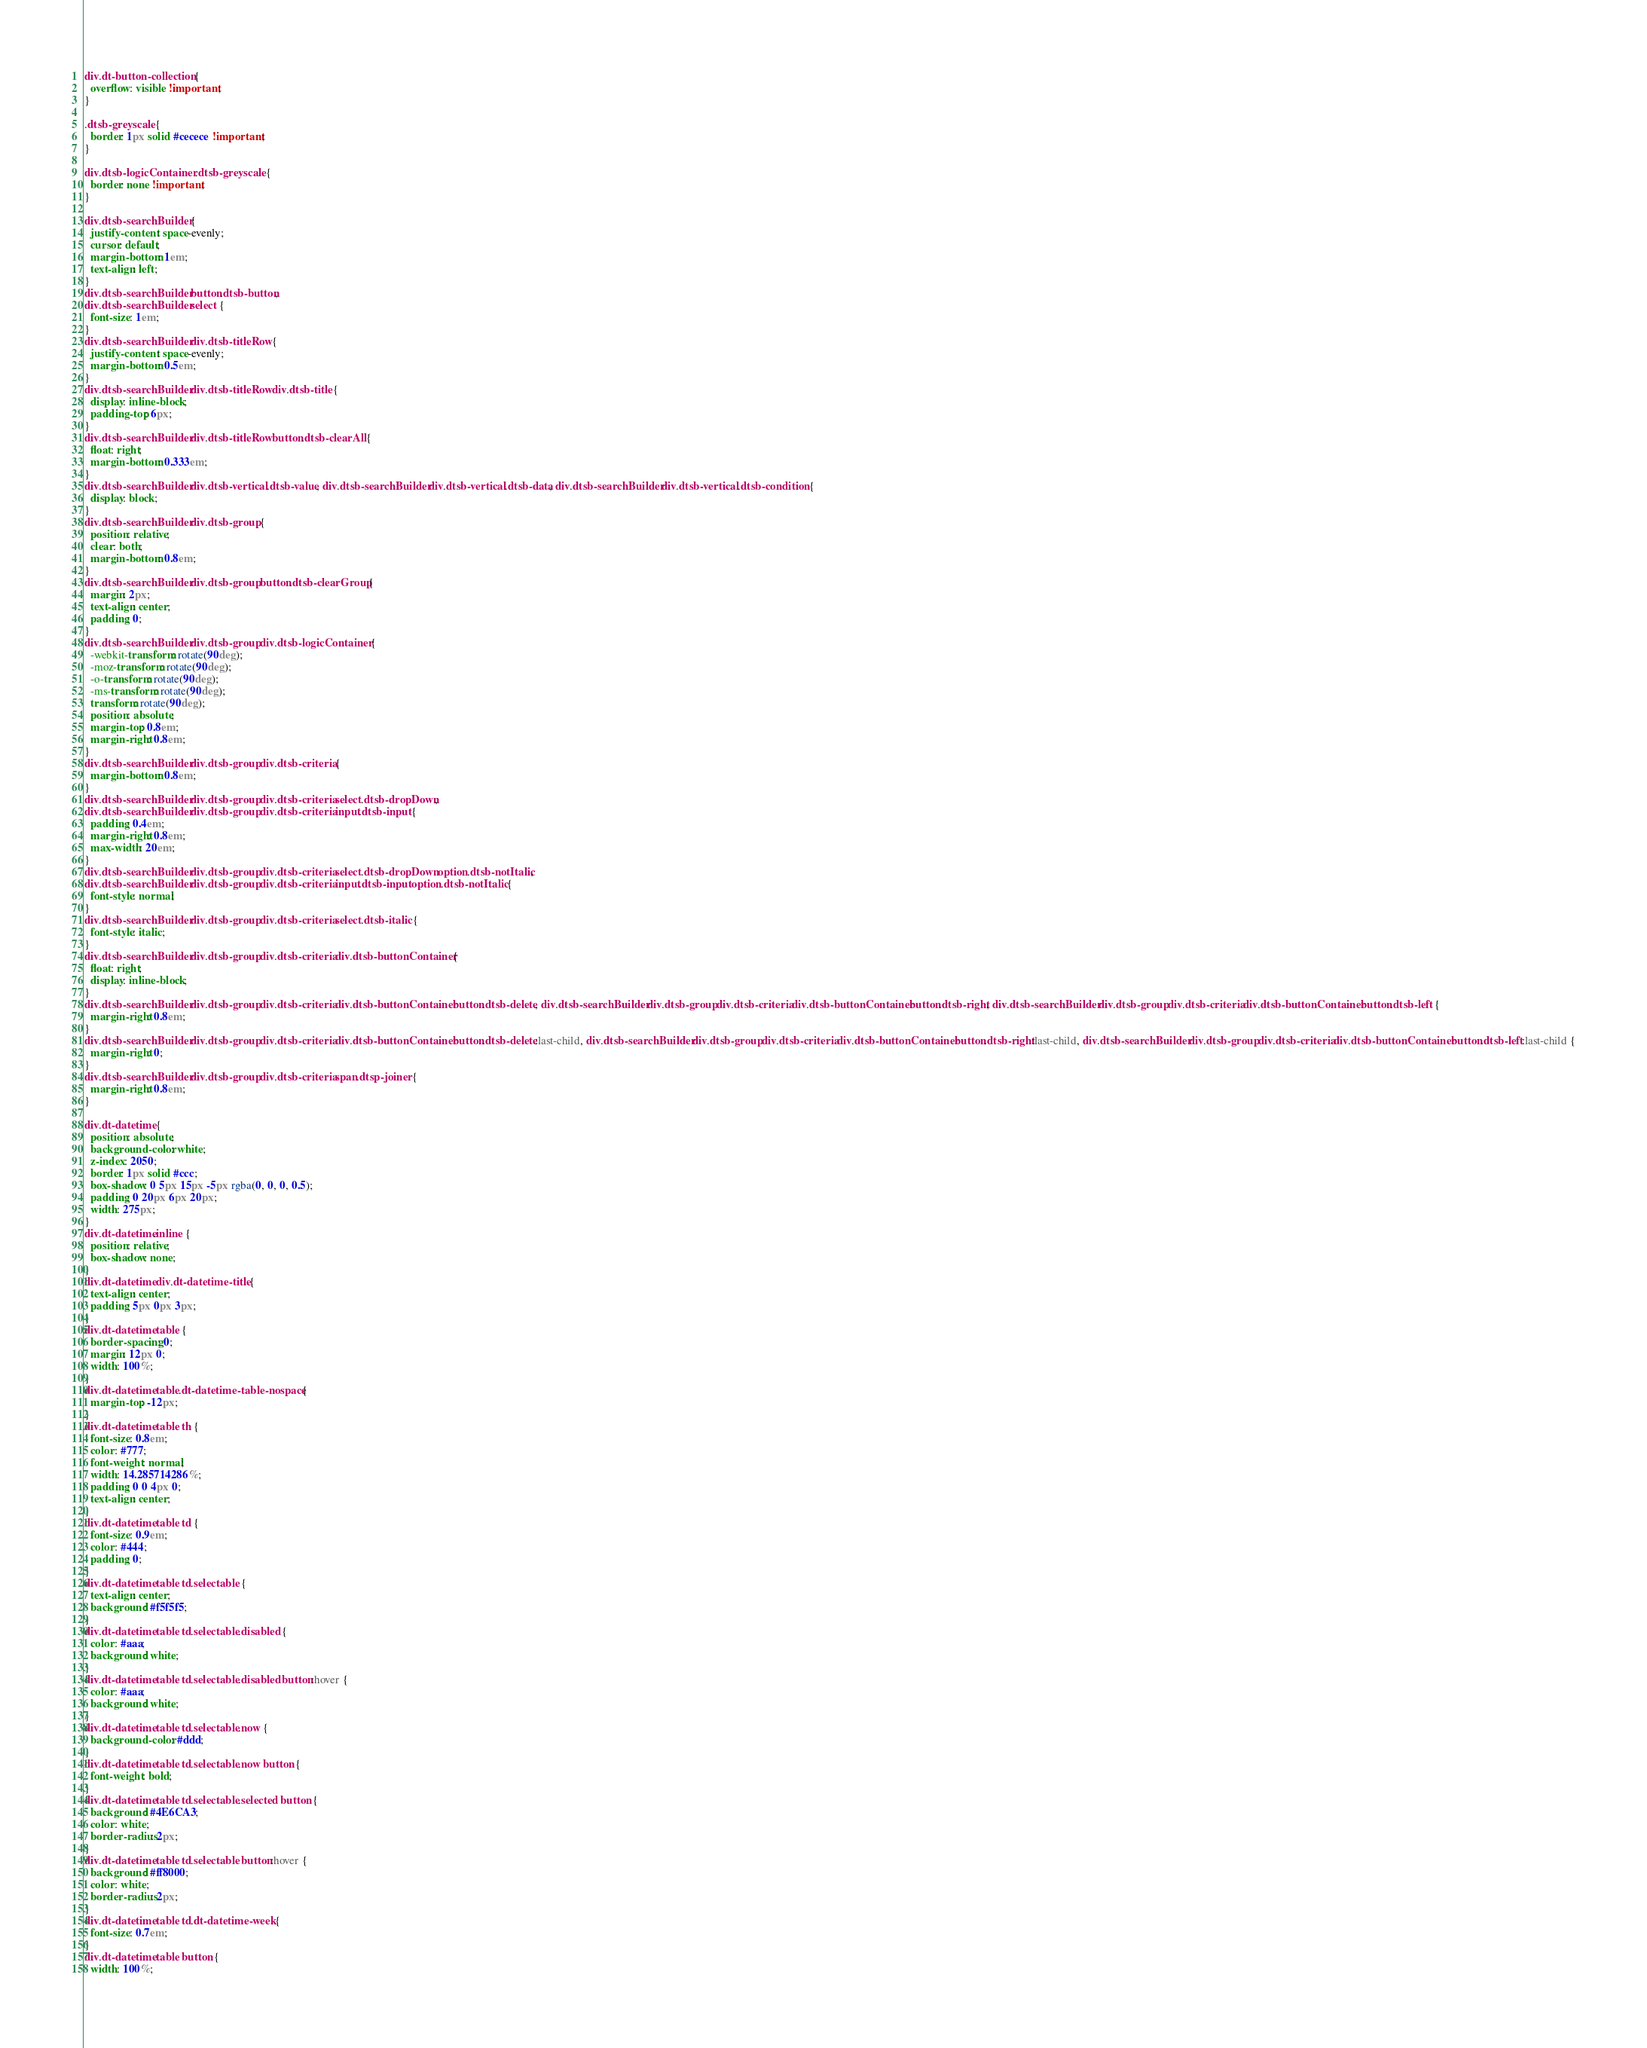Convert code to text. <code><loc_0><loc_0><loc_500><loc_500><_CSS_>div.dt-button-collection {
  overflow: visible !important;
}

.dtsb-greyscale {
  border: 1px solid #cecece !important;
}

div.dtsb-logicContainer .dtsb-greyscale {
  border: none !important;
}

div.dtsb-searchBuilder {
  justify-content: space-evenly;
  cursor: default;
  margin-bottom: 1em;
  text-align: left;
}
div.dtsb-searchBuilder button.dtsb-button,
div.dtsb-searchBuilder select {
  font-size: 1em;
}
div.dtsb-searchBuilder div.dtsb-titleRow {
  justify-content: space-evenly;
  margin-bottom: 0.5em;
}
div.dtsb-searchBuilder div.dtsb-titleRow div.dtsb-title {
  display: inline-block;
  padding-top: 6px;
}
div.dtsb-searchBuilder div.dtsb-titleRow button.dtsb-clearAll {
  float: right;
  margin-bottom: 0.333em;
}
div.dtsb-searchBuilder div.dtsb-vertical .dtsb-value, div.dtsb-searchBuilder div.dtsb-vertical .dtsb-data, div.dtsb-searchBuilder div.dtsb-vertical .dtsb-condition {
  display: block;
}
div.dtsb-searchBuilder div.dtsb-group {
  position: relative;
  clear: both;
  margin-bottom: 0.8em;
}
div.dtsb-searchBuilder div.dtsb-group button.dtsb-clearGroup {
  margin: 2px;
  text-align: center;
  padding: 0;
}
div.dtsb-searchBuilder div.dtsb-group div.dtsb-logicContainer {
  -webkit-transform: rotate(90deg);
  -moz-transform: rotate(90deg);
  -o-transform: rotate(90deg);
  -ms-transform: rotate(90deg);
  transform: rotate(90deg);
  position: absolute;
  margin-top: 0.8em;
  margin-right: 0.8em;
}
div.dtsb-searchBuilder div.dtsb-group div.dtsb-criteria {
  margin-bottom: 0.8em;
}
div.dtsb-searchBuilder div.dtsb-group div.dtsb-criteria select.dtsb-dropDown,
div.dtsb-searchBuilder div.dtsb-group div.dtsb-criteria input.dtsb-input {
  padding: 0.4em;
  margin-right: 0.8em;
  max-width: 20em;
}
div.dtsb-searchBuilder div.dtsb-group div.dtsb-criteria select.dtsb-dropDown option.dtsb-notItalic,
div.dtsb-searchBuilder div.dtsb-group div.dtsb-criteria input.dtsb-input option.dtsb-notItalic {
  font-style: normal;
}
div.dtsb-searchBuilder div.dtsb-group div.dtsb-criteria select.dtsb-italic {
  font-style: italic;
}
div.dtsb-searchBuilder div.dtsb-group div.dtsb-criteria div.dtsb-buttonContainer {
  float: right;
  display: inline-block;
}
div.dtsb-searchBuilder div.dtsb-group div.dtsb-criteria div.dtsb-buttonContainer button.dtsb-delete, div.dtsb-searchBuilder div.dtsb-group div.dtsb-criteria div.dtsb-buttonContainer button.dtsb-right, div.dtsb-searchBuilder div.dtsb-group div.dtsb-criteria div.dtsb-buttonContainer button.dtsb-left {
  margin-right: 0.8em;
}
div.dtsb-searchBuilder div.dtsb-group div.dtsb-criteria div.dtsb-buttonContainer button.dtsb-delete:last-child, div.dtsb-searchBuilder div.dtsb-group div.dtsb-criteria div.dtsb-buttonContainer button.dtsb-right:last-child, div.dtsb-searchBuilder div.dtsb-group div.dtsb-criteria div.dtsb-buttonContainer button.dtsb-left:last-child {
  margin-right: 0;
}
div.dtsb-searchBuilder div.dtsb-group div.dtsb-criteria span.dtsp-joiner {
  margin-right: 0.8em;
}

div.dt-datetime {
  position: absolute;
  background-color: white;
  z-index: 2050;
  border: 1px solid #ccc;
  box-shadow: 0 5px 15px -5px rgba(0, 0, 0, 0.5);
  padding: 0 20px 6px 20px;
  width: 275px;
}
div.dt-datetime.inline {
  position: relative;
  box-shadow: none;
}
div.dt-datetime div.dt-datetime-title {
  text-align: center;
  padding: 5px 0px 3px;
}
div.dt-datetime table {
  border-spacing: 0;
  margin: 12px 0;
  width: 100%;
}
div.dt-datetime table.dt-datetime-table-nospace {
  margin-top: -12px;
}
div.dt-datetime table th {
  font-size: 0.8em;
  color: #777;
  font-weight: normal;
  width: 14.285714286%;
  padding: 0 0 4px 0;
  text-align: center;
}
div.dt-datetime table td {
  font-size: 0.9em;
  color: #444;
  padding: 0;
}
div.dt-datetime table td.selectable {
  text-align: center;
  background: #f5f5f5;
}
div.dt-datetime table td.selectable.disabled {
  color: #aaa;
  background: white;
}
div.dt-datetime table td.selectable.disabled button:hover {
  color: #aaa;
  background: white;
}
div.dt-datetime table td.selectable.now {
  background-color: #ddd;
}
div.dt-datetime table td.selectable.now button {
  font-weight: bold;
}
div.dt-datetime table td.selectable.selected button {
  background: #4E6CA3;
  color: white;
  border-radius: 2px;
}
div.dt-datetime table td.selectable button:hover {
  background: #ff8000;
  color: white;
  border-radius: 2px;
}
div.dt-datetime table td.dt-datetime-week {
  font-size: 0.7em;
}
div.dt-datetime table button {
  width: 100%;</code> 